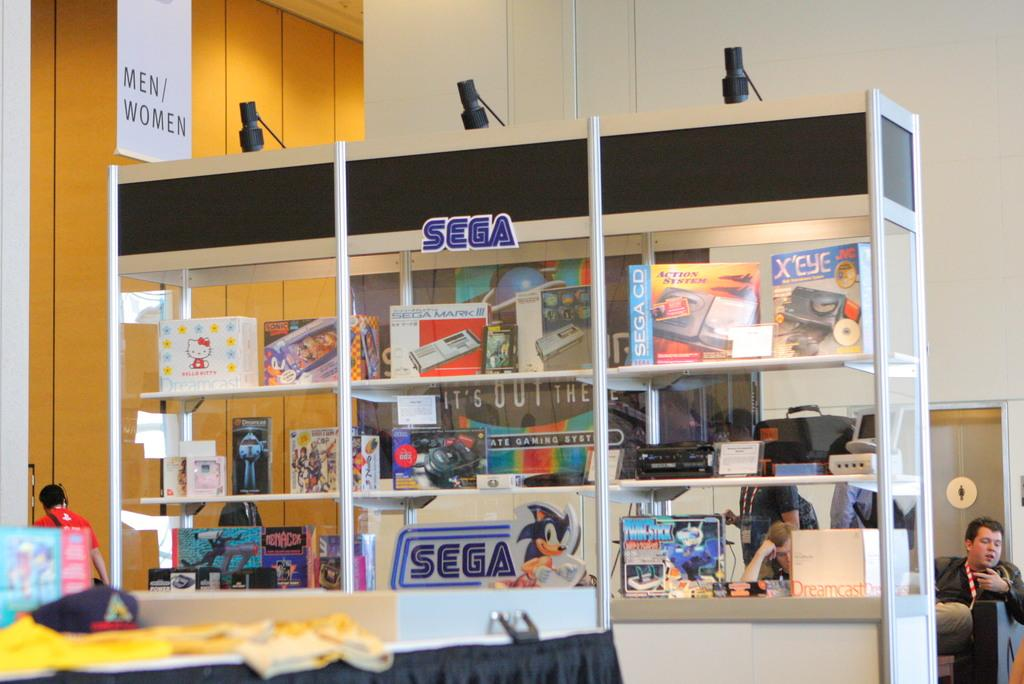<image>
Describe the image concisely. A large shelf containing several sega brande items with a sega logo ion the top middle shelf. 